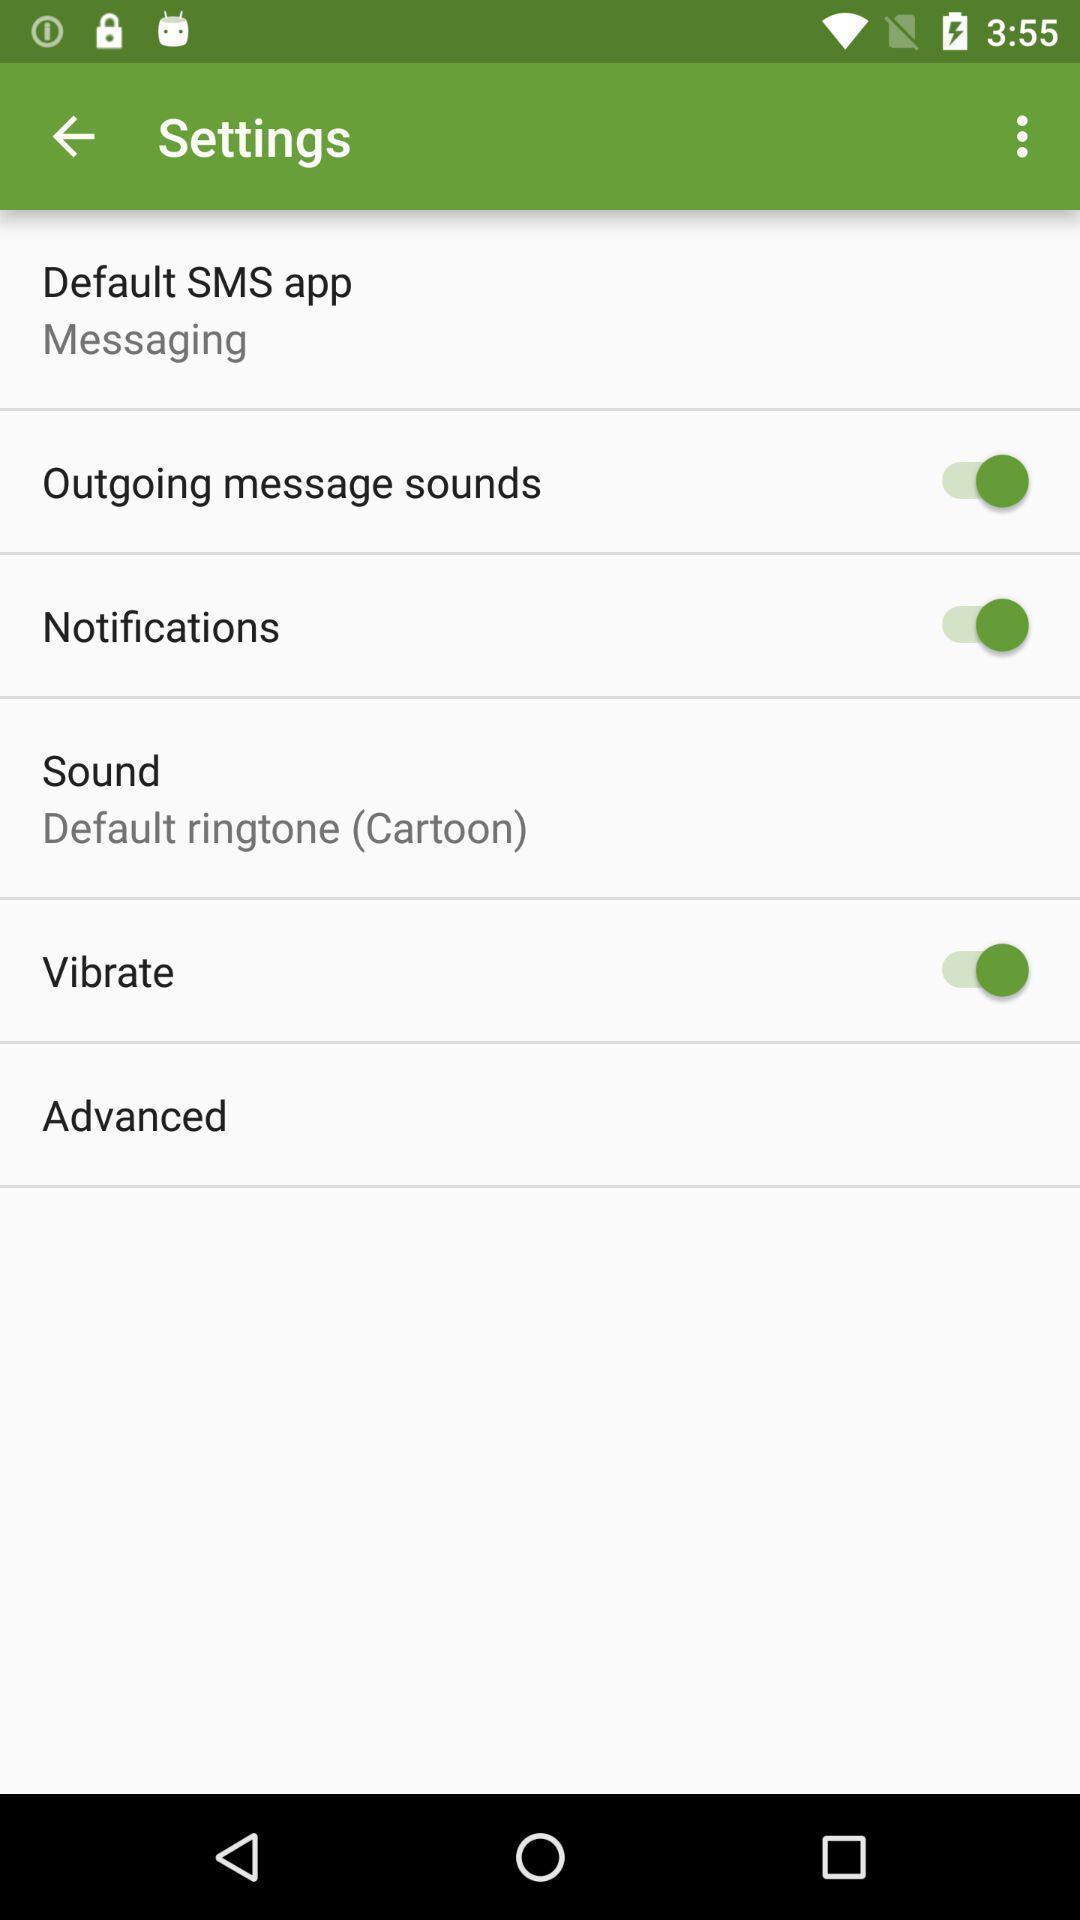What details can you identify in this image? Settings page. 